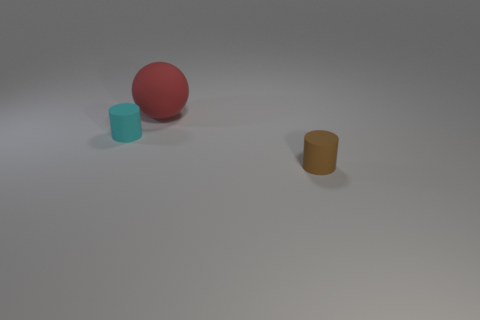Could these objects serve any specific purpose? These objects could be part of a color or shape recognition task, providing a simplistic setup for educational activities or visual experiments. 